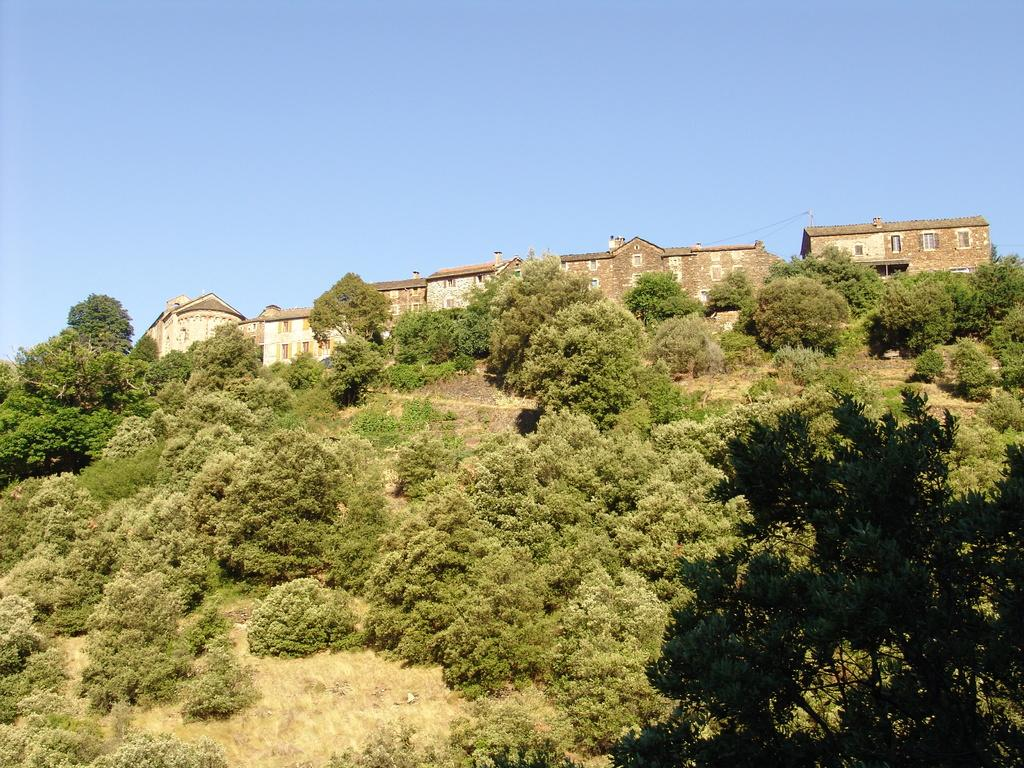What type of structures can be seen in the image? There are buildings in the image. What is located in front of the buildings? There are trees in front of the buildings. What is visible at the top of the image? The sky is visible at the top of the image. What type of surprise apparatus can be seen in the wilderness area of the image? There is no surprise apparatus or wilderness area present in the image; it features buildings and trees. 